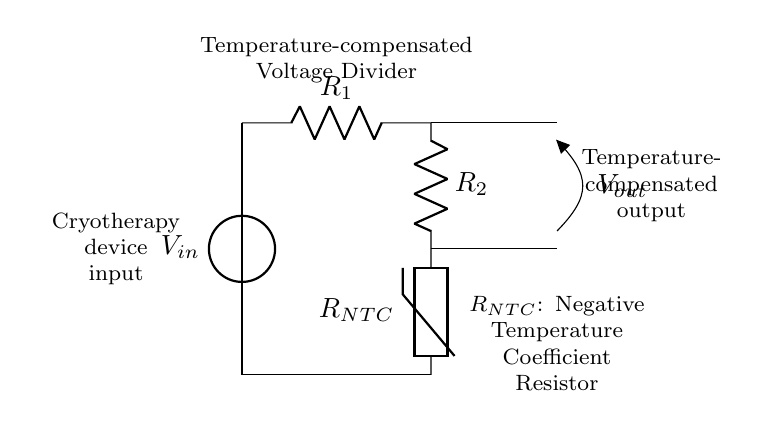What components are present in this circuit? The components in the circuit include a voltage source, two resistors, and a thermistor. The voltage source is the input voltage, and the two resistors, labeled R1 and R2, are part of the voltage divider. The thermistor, labeled RNTC, is included for temperature compensation.
Answer: voltage source, R1, R2, thermistor What does RNTC represent in this circuit? RNTC represents a Negative Temperature Coefficient resistor, which decreases in resistance as the temperature increases. Its role in the circuit is to help maintain a consistent output voltage despite temperature changes encountered during cryotherapy.
Answer: Negative Temperature Coefficient resistor What is the purpose of the voltage divider in this cryotherapy device? The purpose of the voltage divider is to produce a specific output voltage that is proportional to the input voltage to be used in the device; it also compensates for temperature variations to ensure that the output voltage remains stable during treatment.
Answer: maintain consistent voltage Which component is responsible for temperature compensation? The component responsible for temperature compensation is the thermistor (RNTC). It varies its resistance with changes in temperature, which helps to stabilize the output voltage against temperature fluctuations.
Answer: thermistor What is the expected relationship between RNTC and output voltage? The expected relationship is that as the temperature increases, the resistance of RNTC decreases, which can lead to an increase in the output voltage, thereby compensating for temperature variations to stabilize the output.
Answer: increase in output voltage How is the output voltage labeled in the circuit? The output voltage is labeled Vout in the circuit diagram, located between the two resistors and the thermistor, indicating where the voltage is taken from the divider.
Answer: Vout 